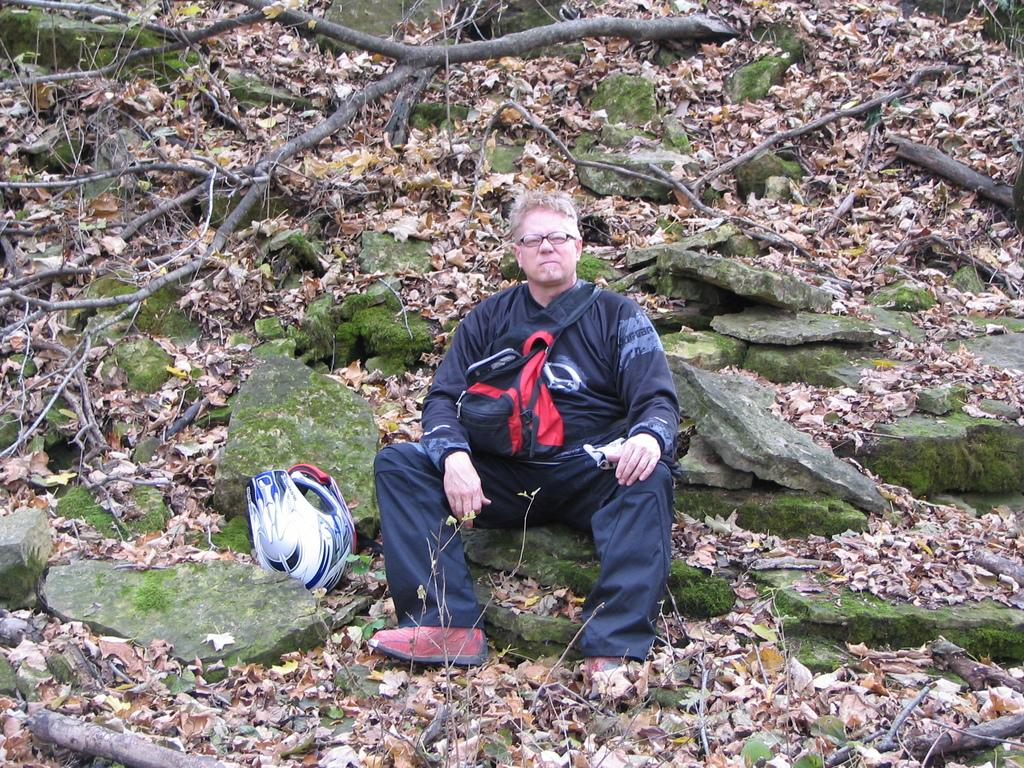What is the person in the image doing? There is a person sitting on a stone in the image. What can be seen in the background of the image? There are stones and leaves visible in the background of the image. What type of vegetation is present in the background? There is a tree in the background of the image. Reasoning: Let'g: Let's think step by step in order to produce the conversation. We start by identifying the main subject in the image, which is the person sitting on a stone. Then, we expand the conversation to include other elements visible in the image, such as the stones, leaves, and tree in the background. Each question is designed to elicit a specific detail about the image that is known from the provided facts. Absurd Question/Answer: What is the cattle's desire in the image? There is no cattle present in the image, so it is not possible to determine their desires. 